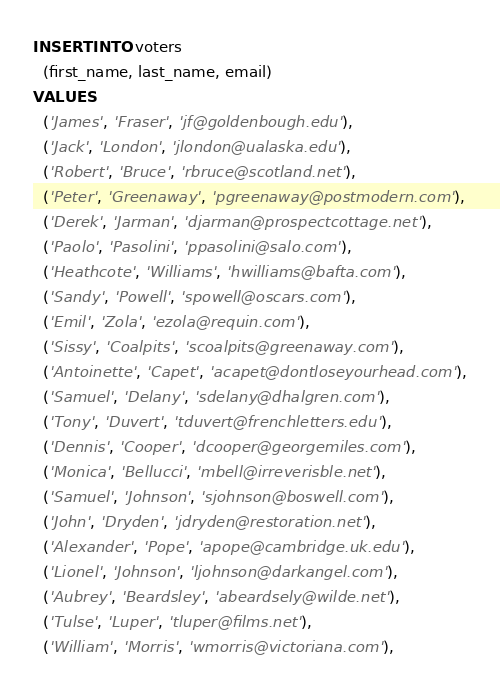<code> <loc_0><loc_0><loc_500><loc_500><_SQL_>INSERT INTO voters
  (first_name, last_name, email)
VALUES
  ('James', 'Fraser', 'jf@goldenbough.edu'),
  ('Jack', 'London', 'jlondon@ualaska.edu'),
  ('Robert', 'Bruce', 'rbruce@scotland.net'),
  ('Peter', 'Greenaway', 'pgreenaway@postmodern.com'),
  ('Derek', 'Jarman', 'djarman@prospectcottage.net'),
  ('Paolo', 'Pasolini', 'ppasolini@salo.com'),
  ('Heathcote', 'Williams', 'hwilliams@bafta.com'),
  ('Sandy', 'Powell', 'spowell@oscars.com'),
  ('Emil', 'Zola', 'ezola@requin.com'),
  ('Sissy', 'Coalpits', 'scoalpits@greenaway.com'),
  ('Antoinette', 'Capet', 'acapet@dontloseyourhead.com'),
  ('Samuel', 'Delany', 'sdelany@dhalgren.com'),
  ('Tony', 'Duvert', 'tduvert@frenchletters.edu'),
  ('Dennis', 'Cooper', 'dcooper@georgemiles.com'),
  ('Monica', 'Bellucci', 'mbell@irreverisble.net'),
  ('Samuel', 'Johnson', 'sjohnson@boswell.com'),
  ('John', 'Dryden', 'jdryden@restoration.net'),
  ('Alexander', 'Pope', 'apope@cambridge.uk.edu'),
  ('Lionel', 'Johnson', 'ljohnson@darkangel.com'),
  ('Aubrey', 'Beardsley', 'abeardsely@wilde.net'),
  ('Tulse', 'Luper', 'tluper@films.net'),
  ('William', 'Morris', 'wmorris@victoriana.com'),</code> 